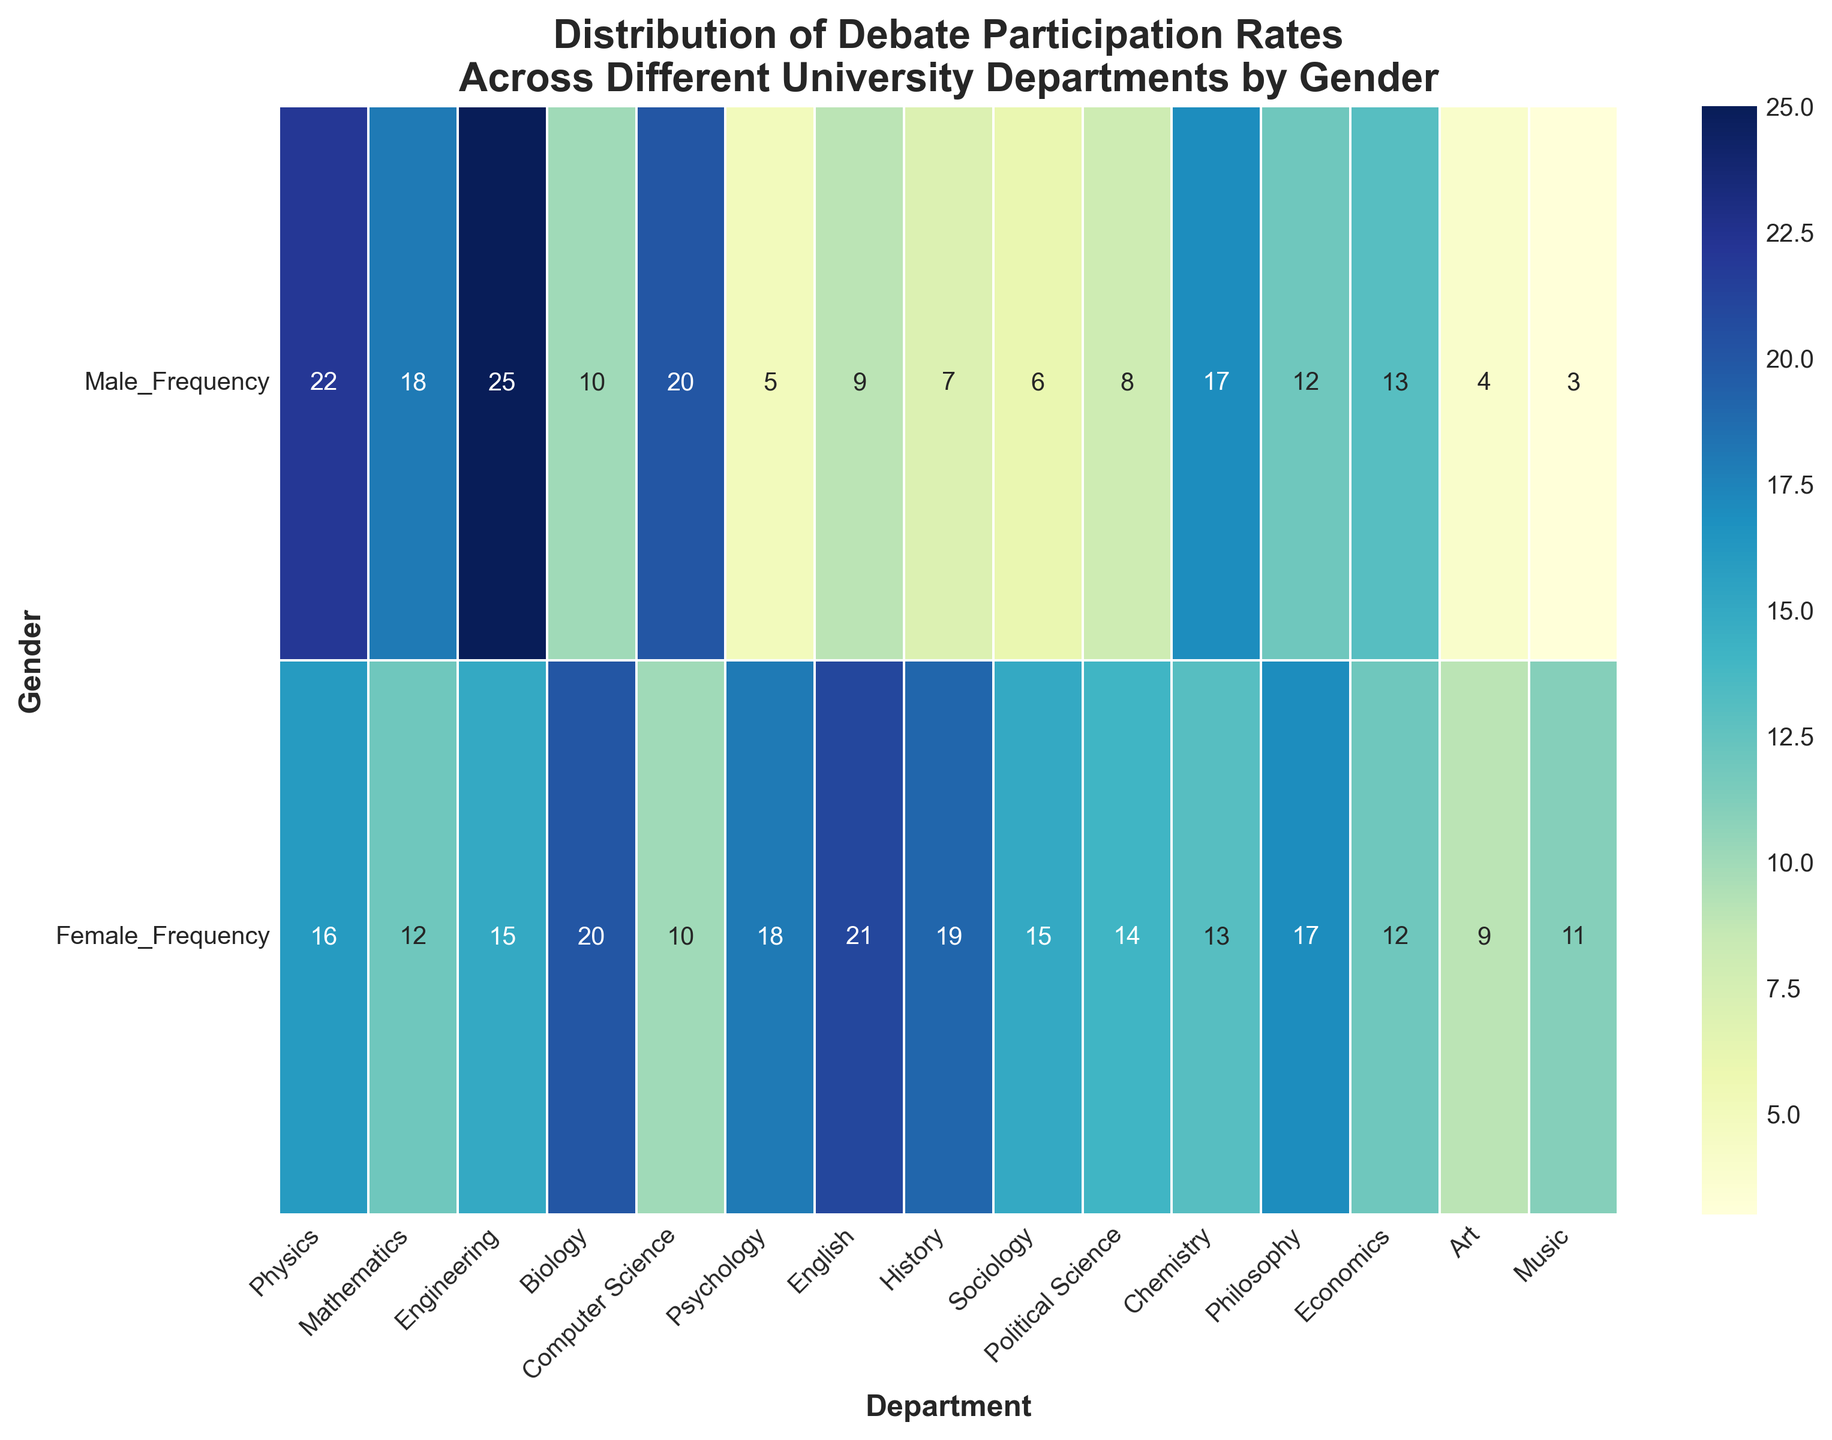Which department has the highest number of male participants? Look at the heatmap and identify the cell with the highest value under the "Male" row. "Engineering" has the highest number of male participants which is 25.
Answer: Engineering Which gender has more participants in the Psychology department, and by how many? Find the values in the Psychology column for both genders. Male: 5, Female: 18. Female participants are more by 18 - 5 = 13.
Answer: Female, 13 What is the total number of participants in the Physics department? Add the number of male and female participants in the Physics department. Male: 22, Female: 16. Total: 22 + 16 = 38.
Answer: 38 Which department shows an equal number of male and female participants? Scan the heatmap to find a department where the values for Male and Female are equal. In Economics, both have 12 participants.
Answer: Economics What is the average number of female participants across all departments? Sum up the number of female participants in all departments and divide by the total number of departments (15). The sum is 224, so the average: 224 / 15 ≈ 14.93.
Answer: ≈14.93 Which department contributes the most to the total number of female participants? Identify the department with the highest value in the Female row. English has the highest number of female participants, 21.
Answer: English Can you identify two departments where the number of male participants is exactly double the number of female participants? Scan through the heatmap to find departments where the Male value is twice the Female value. For Computer Science (20 and 10) and Chemistry (17 and 13.
Answer: Computer Science, Chemistry In the Sociology department, what proportion of the participants are male? Calculate the proportion of male participants in Sociology. Male: 6, Total: 6 + 15 = 21. Proportion: 6 / 21 ≈ 0.286 or 28.6%.
Answer: ≈28.6% Which department has the smallest overall participation, and what is the total number? Identify the department with the lowest sum of male and female participants. Music department: Male: 3, Female: 11, Total: 3 + 11 = 14.
Answer: Music, 14 